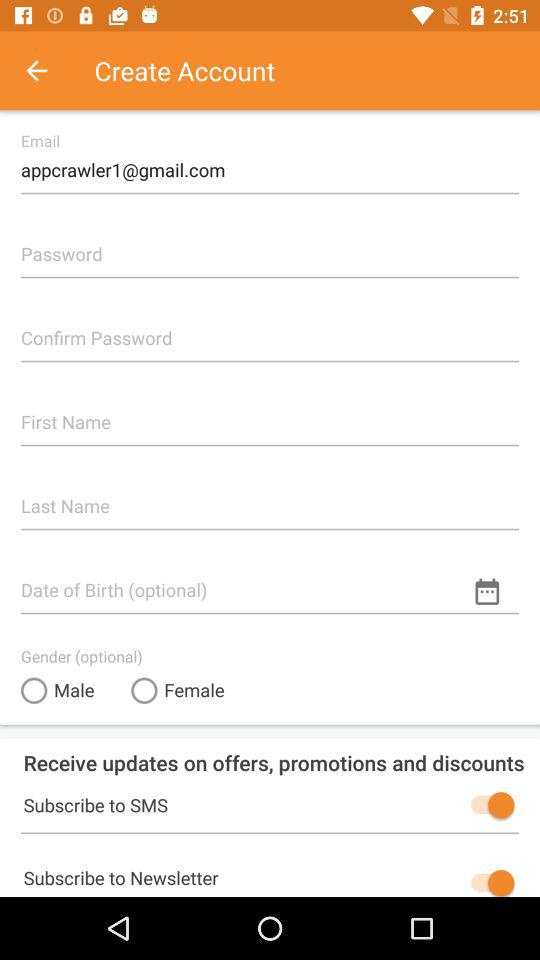What is the status of "Subscribe to SMS"? The status is "on". 